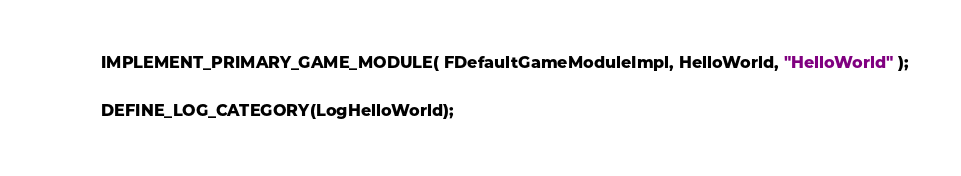Convert code to text. <code><loc_0><loc_0><loc_500><loc_500><_C++_>IMPLEMENT_PRIMARY_GAME_MODULE( FDefaultGameModuleImpl, HelloWorld, "HelloWorld" );

DEFINE_LOG_CATEGORY(LogHelloWorld);
</code> 